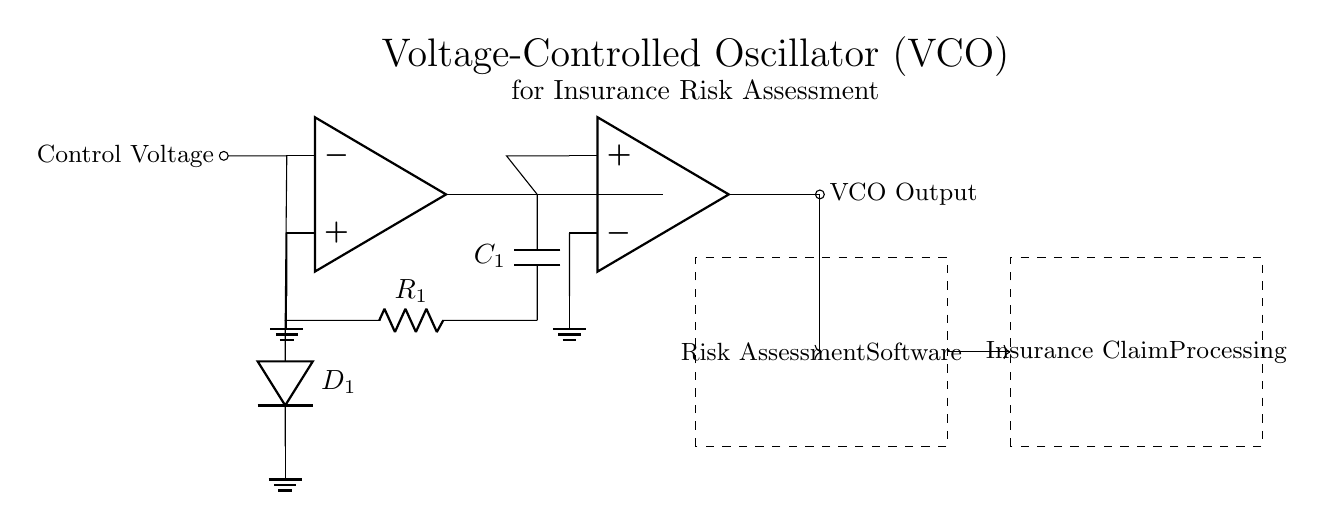What is the type of oscillator in the circuit? The circuit shows a voltage-controlled oscillator, which is evident from the use of an op-amp in the configuration typical of VCOs.
Answer: Voltage-controlled oscillator What component provides the control voltage? The control voltage is provided to the inverting input of the op-amp, indicated by the label "Control Voltage" connected to the op-amp.
Answer: Control Voltage What is the role of the varactor diode in the circuit? The varactor diode is connected to the resistor and ground, where it provides varying capacitance based on the control voltage, thus controlling the oscillator's frequency.
Answer: Varying capacitance What components are used in the feedback network? The feedback network consists of a capacitor labeled "C1" and a resistor labeled "R1" that connects back to the inverting input of the op-amp.
Answer: C1 and R1 How does the output of the VCO interface with the risk assessment software? The output of the VCO is connected to the risk assessment software block via an arrow, indicating that the output signal is sent directly to the software for processing.
Answer: Direct connection What is the output configuration of the voltage-controlled oscillator? The configuration includes an output buffer op-amp that allows the voltage-controlled oscillator output to be buffered before sending the signal to the next stage.
Answer: Output buffer What is the purpose of the dashed box labeled "Insurance Claim Processing"? The dashed box represents a functional block where the processed risk assessment data is presumably utilized further in the insurance claim processing workflow.
Answer: Insurance claim processing 